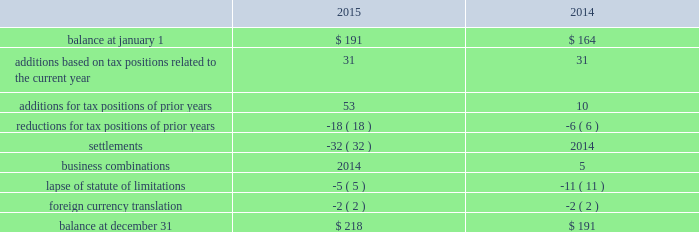Uncertain tax positions the following is a reconciliation of the company's beginning and ending amount of uncertain tax positions ( in millions ) : .
The company's liability for uncertain tax positions as of december 31 , 2015 , 2014 , and 2013 , includes $ 180 million , $ 154 million , and $ 141 million , respectively , related to amounts that would impact the effective tax rate if recognized .
It is possible that the amount of unrecognized tax benefits may change in the next twelve months ; however , we do not expect the change to have a significant impact on our consolidated statements of income or consolidated balance sheets .
These changes may be the result of settlements of ongoing audits .
At this time , an estimate of the range of the reasonably possible outcomes within the twelve months cannot be made .
The company recognizes interest and penalties related to uncertain tax positions in its provision for income taxes .
The company accrued potential interest and penalties of $ 2 million , $ 4 million , and $ 2 million in 2015 , 2014 , and 2013 , respectively .
The company recorded a liability for interest and penalties of $ 33 million , $ 31 million , and $ 27 million as of december 31 , 2015 , 2014 , and 2013 , respectively .
The company and its subsidiaries file income tax returns in their respective jurisdictions .
The company has substantially concluded all u.s .
Federal income tax matters for years through 2007 .
Material u.s .
State and local income tax jurisdiction examinations have been concluded for years through 2005 .
The company has concluded income tax examinations in its primary non-u.s .
Jurisdictions through 2005 .
Shareholders' equity distributable reserves as a u.k .
Incorporated company , the company is required under u.k .
Law to have available "distributable reserves" to make share repurchases or pay dividends to shareholders .
Distributable reserves may be created through the earnings of the u.k .
Parent company and , amongst other methods , through a reduction in share capital approved by the english companies court .
Distributable reserves are not linked to a u.s .
Gaap reported amount ( e.g. , retained earnings ) .
As of december 31 , 2015 and 2014 , the company had distributable reserves in excess of $ 2.1 billion and $ 4.0 billion , respectively .
Ordinary shares in april 2012 , the company's board of directors authorized a share repurchase program under which up to $ 5.0 billion of class a ordinary shares may be repurchased ( "2012 share repurchase program" ) .
In november 2014 , the company's board of directors authorized a new $ 5.0 billion share repurchase program in addition to the existing program ( "2014 share repurchase program" and , together , the "repurchase programs" ) .
Under each program , shares may be repurchased through the open market or in privately negotiated transactions , based on prevailing market conditions , funded from available capital .
During 2015 , the company repurchased 16.0 million shares at an average price per share of $ 97.04 for a total cost of $ 1.6 billion under the repurchase programs .
During 2014 , the company repurchased 25.8 million shares at an average price per share of $ 87.18 for a total cost of $ 2.3 billion under the 2012 share repurchase plan .
In august 2015 , the $ 5 billion of class a ordinary shares authorized under the 2012 share repurchase program was exhausted .
At december 31 , 2015 , the remaining authorized amount for share repurchase under the 2014 share repurchase program is $ 4.1 billion .
Under the repurchase programs , the company repurchased a total of 78.1 million shares for an aggregate cost of $ 5.9 billion. .
In 2015 what was the percentage change in the uncertain tax positions? 
Computations: (218 - 191)
Answer: 27.0. 